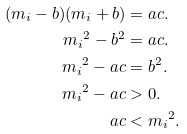<formula> <loc_0><loc_0><loc_500><loc_500>( m _ { i } - b ) ( m _ { i } + b ) & = a c . \\ { m _ { i } } ^ { 2 } - b ^ { 2 } & = a c . \\ { m _ { i } } ^ { 2 } - a c & = b ^ { 2 } . \\ { m _ { i } } ^ { 2 } - a c & > 0 . \\ a c & < { m _ { i } } ^ { 2 } .</formula> 